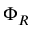<formula> <loc_0><loc_0><loc_500><loc_500>\Phi _ { R }</formula> 